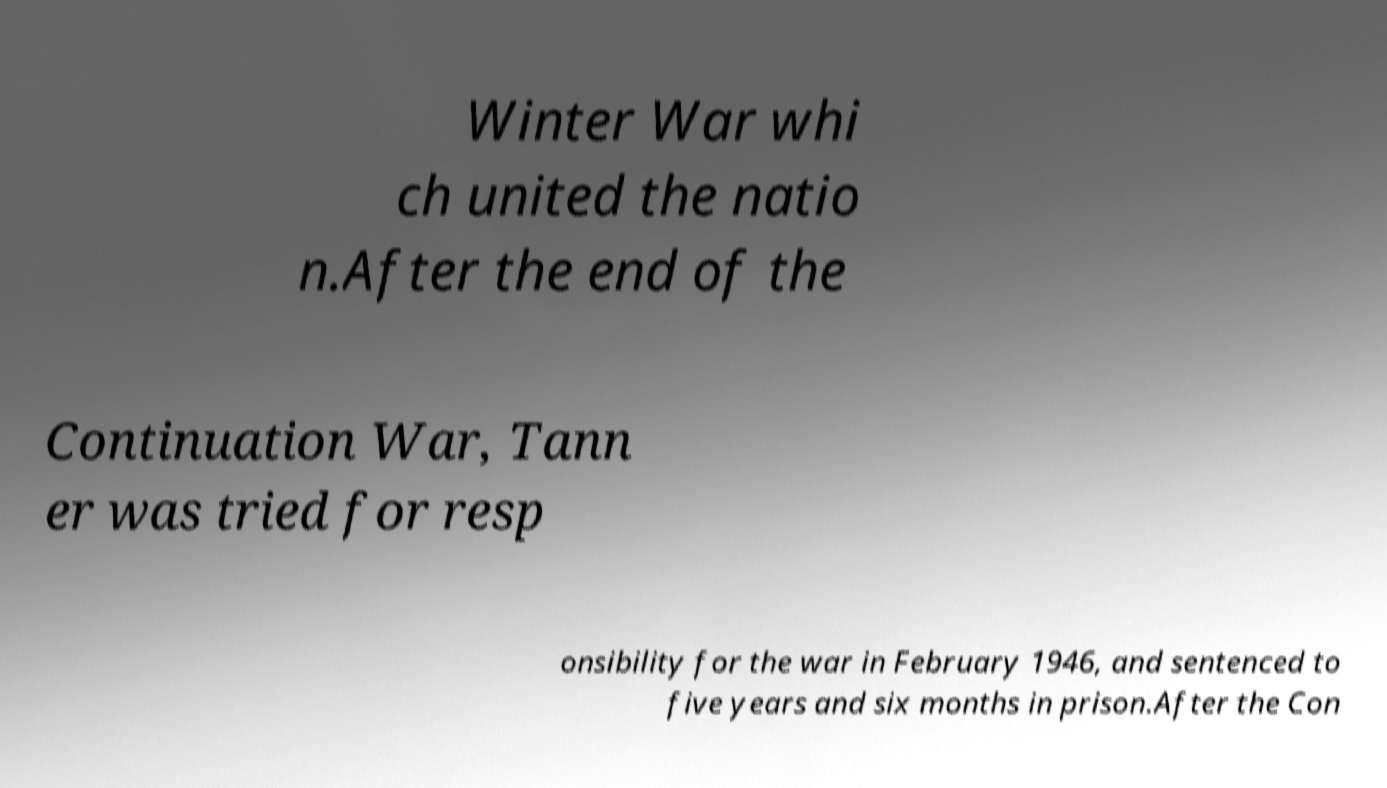I need the written content from this picture converted into text. Can you do that? Winter War whi ch united the natio n.After the end of the Continuation War, Tann er was tried for resp onsibility for the war in February 1946, and sentenced to five years and six months in prison.After the Con 